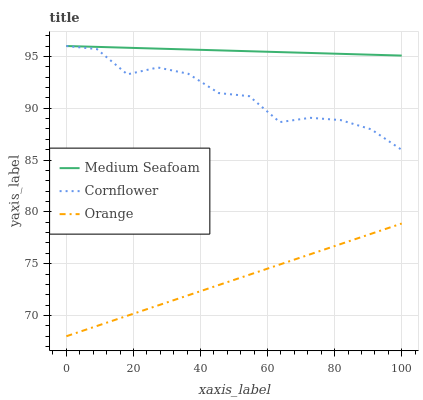Does Orange have the minimum area under the curve?
Answer yes or no. Yes. Does Medium Seafoam have the maximum area under the curve?
Answer yes or no. Yes. Does Cornflower have the minimum area under the curve?
Answer yes or no. No. Does Cornflower have the maximum area under the curve?
Answer yes or no. No. Is Orange the smoothest?
Answer yes or no. Yes. Is Cornflower the roughest?
Answer yes or no. Yes. Is Medium Seafoam the smoothest?
Answer yes or no. No. Is Medium Seafoam the roughest?
Answer yes or no. No. Does Orange have the lowest value?
Answer yes or no. Yes. Does Cornflower have the lowest value?
Answer yes or no. No. Does Medium Seafoam have the highest value?
Answer yes or no. Yes. Is Orange less than Medium Seafoam?
Answer yes or no. Yes. Is Medium Seafoam greater than Orange?
Answer yes or no. Yes. Does Cornflower intersect Medium Seafoam?
Answer yes or no. Yes. Is Cornflower less than Medium Seafoam?
Answer yes or no. No. Is Cornflower greater than Medium Seafoam?
Answer yes or no. No. Does Orange intersect Medium Seafoam?
Answer yes or no. No. 